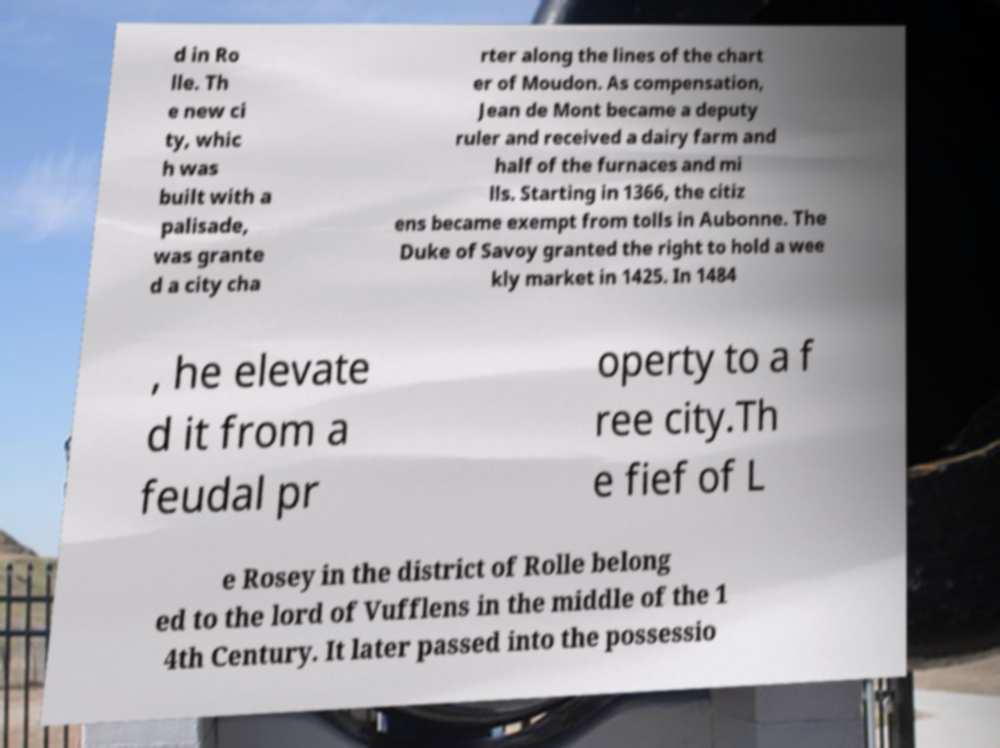For documentation purposes, I need the text within this image transcribed. Could you provide that? d in Ro lle. Th e new ci ty, whic h was built with a palisade, was grante d a city cha rter along the lines of the chart er of Moudon. As compensation, Jean de Mont became a deputy ruler and received a dairy farm and half of the furnaces and mi lls. Starting in 1366, the citiz ens became exempt from tolls in Aubonne. The Duke of Savoy granted the right to hold a wee kly market in 1425. In 1484 , he elevate d it from a feudal pr operty to a f ree city.Th e fief of L e Rosey in the district of Rolle belong ed to the lord of Vufflens in the middle of the 1 4th Century. It later passed into the possessio 